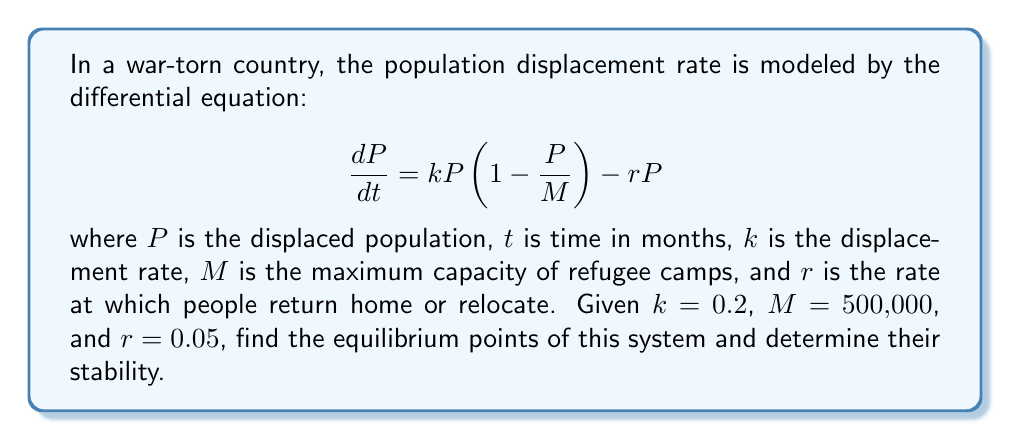What is the answer to this math problem? To find the equilibrium points, we set $\frac{dP}{dt} = 0$:

$$0 = kP(1 - \frac{P}{M}) - rP$$

Factoring out $P$:

$$0 = P(k(1 - \frac{P}{M}) - r)$$

This equation is satisfied when $P = 0$ or when the term in parentheses equals zero.

For the second case:

$$k(1 - \frac{P}{M}) - r = 0$$
$$k - \frac{kP}{M} - r = 0$$
$$k - r = \frac{kP}{M}$$
$$P = \frac{M(k-r)}{k}$$

Substituting the given values:

$$P = \frac{500,000(0.2-0.05)}{0.2} = 375,000$$

To determine stability, we evaluate the derivative of $\frac{dP}{dt}$ with respect to $P$ at each equilibrium point:

$$\frac{d}{dP}(\frac{dP}{dt}) = k(1 - \frac{2P}{M}) - r$$

At $P = 0$:
$$\frac{d}{dP}(\frac{dP}{dt}) = k - r = 0.2 - 0.05 = 0.15 > 0$$
This is unstable.

At $P = 375,000$:
$$\frac{d}{dP}(\frac{dP}{dt}) = 0.2(1 - \frac{2(375,000)}{500,000}) - 0.05 = -0.15 < 0$$
This is stable.
Answer: Equilibrium points: $P = 0$ (unstable) and $P = 375,000$ (stable) 